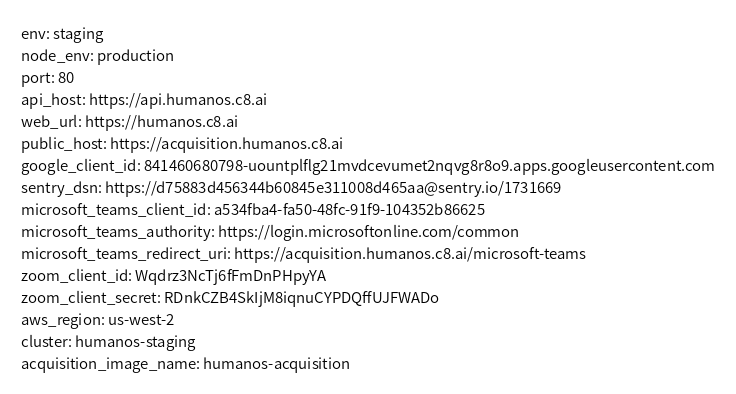Convert code to text. <code><loc_0><loc_0><loc_500><loc_500><_YAML_>env: staging
node_env: production
port: 80
api_host: https://api.humanos.c8.ai
web_url: https://humanos.c8.ai
public_host: https://acquisition.humanos.c8.ai
google_client_id: 841460680798-uountplflg21mvdcevumet2nqvg8r8o9.apps.googleusercontent.com
sentry_dsn: https://d75883d456344b60845e311008d465aa@sentry.io/1731669
microsoft_teams_client_id: a534fba4-fa50-48fc-91f9-104352b86625
microsoft_teams_authority: https://login.microsoftonline.com/common
microsoft_teams_redirect_uri: https://acquisition.humanos.c8.ai/microsoft-teams
zoom_client_id: Wqdrz3NcTj6fFmDnPHpyYA
zoom_client_secret: RDnkCZB4SkIjM8iqnuCYPDQffUJFWADo
aws_region: us-west-2
cluster: humanos-staging
acquisition_image_name: humanos-acquisition</code> 